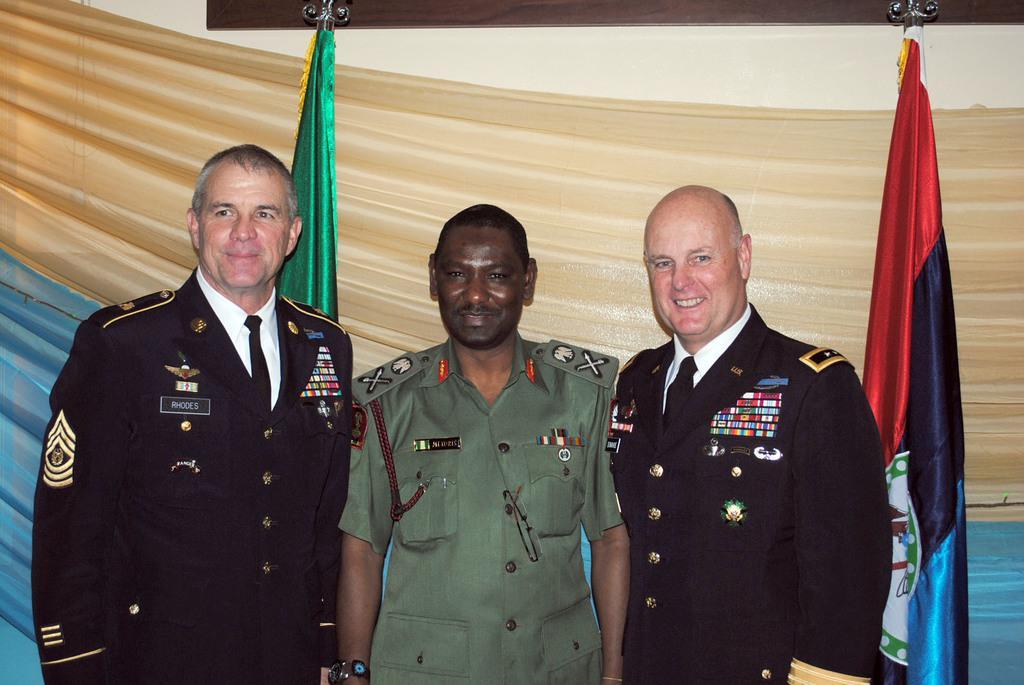In one or two sentences, can you explain what this image depicts? In this image I can see three persons standing. The person in the middle wearing uniform, background I can see two flags which are in red, blue and green color, and I can see wall in cream color. 